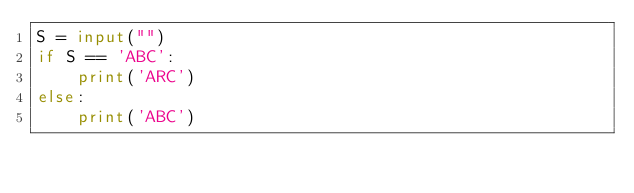Convert code to text. <code><loc_0><loc_0><loc_500><loc_500><_Python_>S = input("")
if S == 'ABC':
    print('ARC')
else:
    print('ABC')</code> 